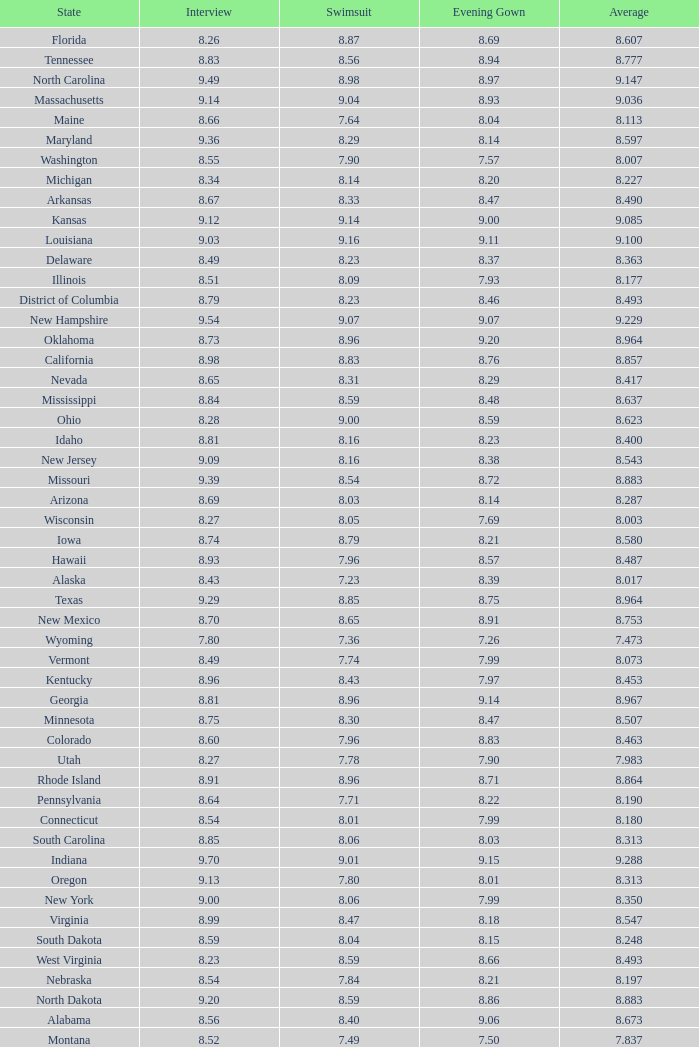Tell me the sum of interview for evening gown more than 8.37 and average of 8.363 None. 